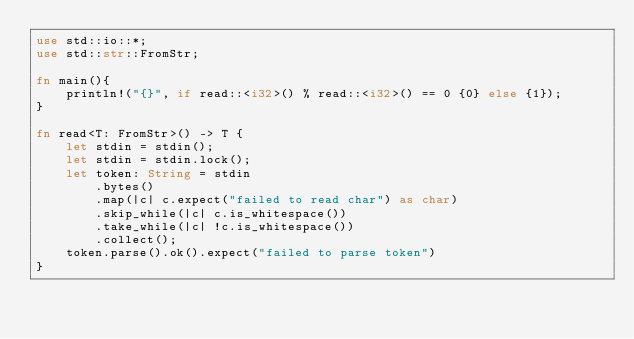Convert code to text. <code><loc_0><loc_0><loc_500><loc_500><_Rust_>use std::io::*;
use std::str::FromStr;

fn main(){
    println!("{}", if read::<i32>() % read::<i32>() == 0 {0} else {1});
}

fn read<T: FromStr>() -> T {
    let stdin = stdin();
    let stdin = stdin.lock();
    let token: String = stdin
        .bytes()
        .map(|c| c.expect("failed to read char") as char) 
        .skip_while(|c| c.is_whitespace())
        .take_while(|c| !c.is_whitespace())
        .collect();
    token.parse().ok().expect("failed to parse token")
}</code> 